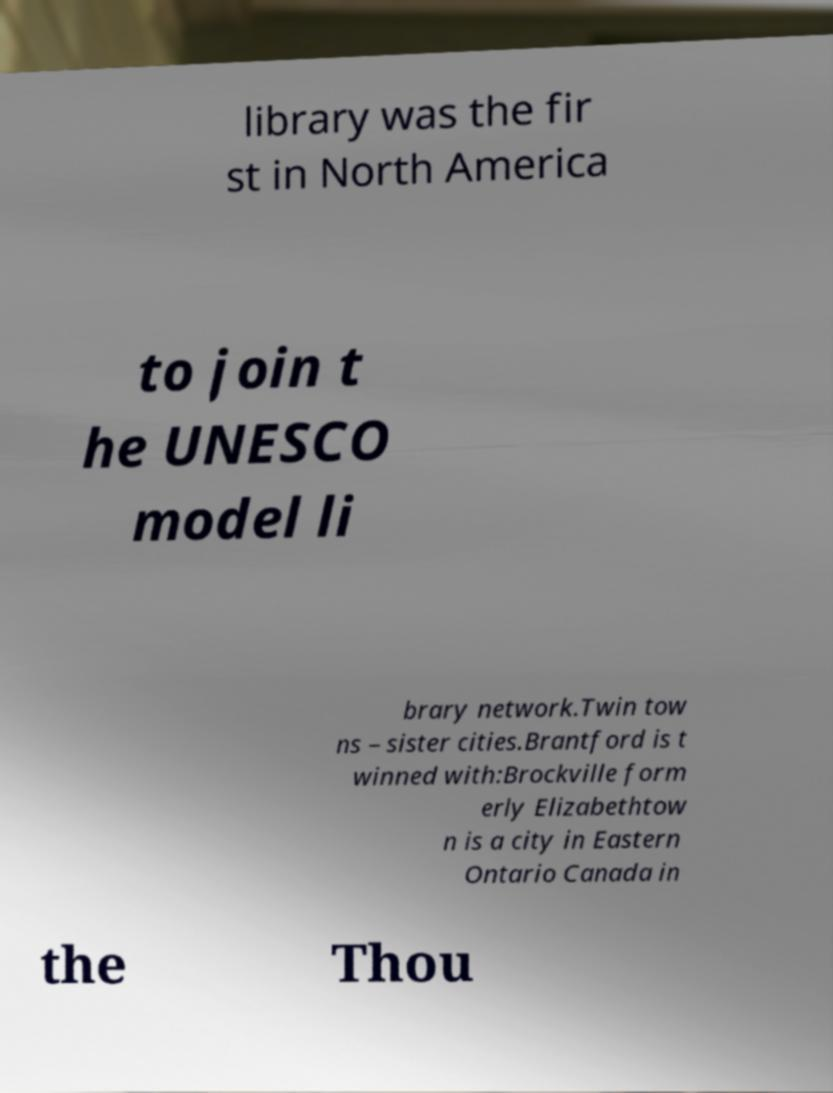Please identify and transcribe the text found in this image. library was the fir st in North America to join t he UNESCO model li brary network.Twin tow ns – sister cities.Brantford is t winned with:Brockville form erly Elizabethtow n is a city in Eastern Ontario Canada in the Thou 